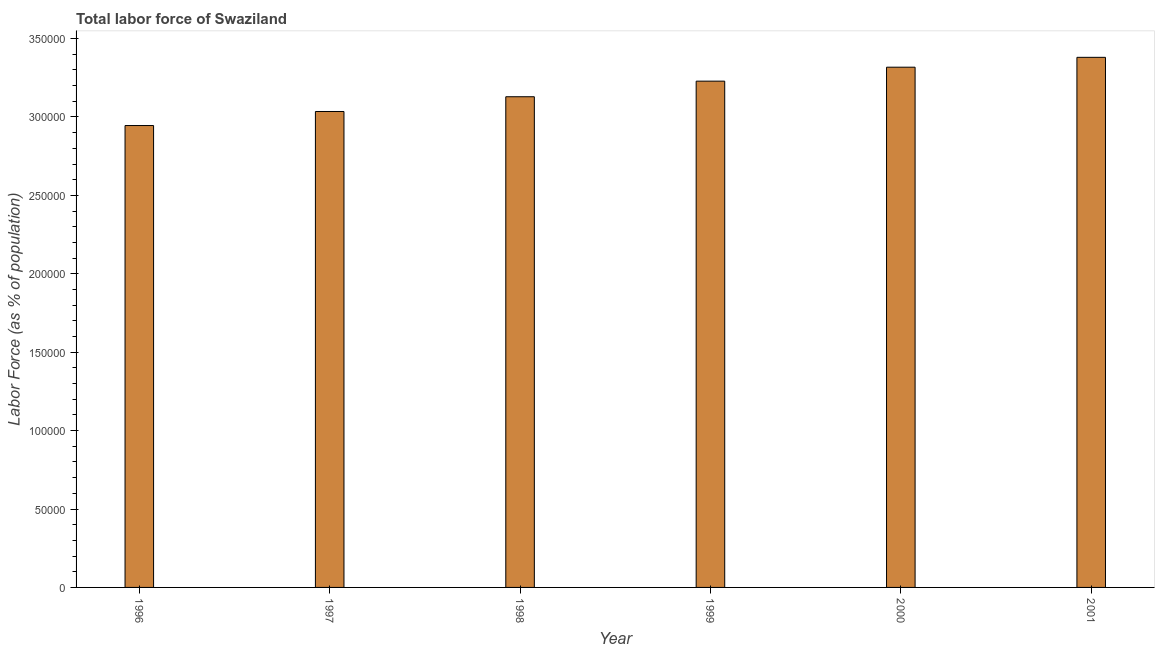Does the graph contain any zero values?
Give a very brief answer. No. Does the graph contain grids?
Your answer should be compact. No. What is the title of the graph?
Make the answer very short. Total labor force of Swaziland. What is the label or title of the X-axis?
Your answer should be compact. Year. What is the label or title of the Y-axis?
Your answer should be very brief. Labor Force (as % of population). What is the total labor force in 1999?
Make the answer very short. 3.23e+05. Across all years, what is the maximum total labor force?
Your response must be concise. 3.38e+05. Across all years, what is the minimum total labor force?
Make the answer very short. 2.95e+05. In which year was the total labor force maximum?
Make the answer very short. 2001. In which year was the total labor force minimum?
Make the answer very short. 1996. What is the sum of the total labor force?
Offer a very short reply. 1.90e+06. What is the difference between the total labor force in 1996 and 1998?
Offer a terse response. -1.84e+04. What is the average total labor force per year?
Keep it short and to the point. 3.17e+05. What is the median total labor force?
Your answer should be compact. 3.18e+05. What is the ratio of the total labor force in 1996 to that in 1998?
Your response must be concise. 0.94. Is the difference between the total labor force in 1996 and 2000 greater than the difference between any two years?
Your response must be concise. No. What is the difference between the highest and the second highest total labor force?
Offer a very short reply. 6291. What is the difference between the highest and the lowest total labor force?
Give a very brief answer. 4.35e+04. How many years are there in the graph?
Provide a succinct answer. 6. Are the values on the major ticks of Y-axis written in scientific E-notation?
Offer a very short reply. No. What is the Labor Force (as % of population) in 1996?
Provide a short and direct response. 2.95e+05. What is the Labor Force (as % of population) in 1997?
Offer a terse response. 3.04e+05. What is the Labor Force (as % of population) of 1998?
Your answer should be compact. 3.13e+05. What is the Labor Force (as % of population) in 1999?
Offer a very short reply. 3.23e+05. What is the Labor Force (as % of population) of 2000?
Provide a short and direct response. 3.32e+05. What is the Labor Force (as % of population) in 2001?
Keep it short and to the point. 3.38e+05. What is the difference between the Labor Force (as % of population) in 1996 and 1997?
Your response must be concise. -8958. What is the difference between the Labor Force (as % of population) in 1996 and 1998?
Your answer should be very brief. -1.84e+04. What is the difference between the Labor Force (as % of population) in 1996 and 1999?
Keep it short and to the point. -2.83e+04. What is the difference between the Labor Force (as % of population) in 1996 and 2000?
Your answer should be very brief. -3.72e+04. What is the difference between the Labor Force (as % of population) in 1996 and 2001?
Provide a short and direct response. -4.35e+04. What is the difference between the Labor Force (as % of population) in 1997 and 1998?
Offer a terse response. -9414. What is the difference between the Labor Force (as % of population) in 1997 and 1999?
Ensure brevity in your answer.  -1.94e+04. What is the difference between the Labor Force (as % of population) in 1997 and 2000?
Your answer should be compact. -2.83e+04. What is the difference between the Labor Force (as % of population) in 1997 and 2001?
Make the answer very short. -3.45e+04. What is the difference between the Labor Force (as % of population) in 1998 and 1999?
Give a very brief answer. -9939. What is the difference between the Labor Force (as % of population) in 1998 and 2000?
Provide a succinct answer. -1.88e+04. What is the difference between the Labor Force (as % of population) in 1998 and 2001?
Your answer should be very brief. -2.51e+04. What is the difference between the Labor Force (as % of population) in 1999 and 2000?
Your response must be concise. -8900. What is the difference between the Labor Force (as % of population) in 1999 and 2001?
Give a very brief answer. -1.52e+04. What is the difference between the Labor Force (as % of population) in 2000 and 2001?
Offer a terse response. -6291. What is the ratio of the Labor Force (as % of population) in 1996 to that in 1997?
Offer a very short reply. 0.97. What is the ratio of the Labor Force (as % of population) in 1996 to that in 1998?
Ensure brevity in your answer.  0.94. What is the ratio of the Labor Force (as % of population) in 1996 to that in 1999?
Ensure brevity in your answer.  0.91. What is the ratio of the Labor Force (as % of population) in 1996 to that in 2000?
Make the answer very short. 0.89. What is the ratio of the Labor Force (as % of population) in 1996 to that in 2001?
Your answer should be very brief. 0.87. What is the ratio of the Labor Force (as % of population) in 1997 to that in 1998?
Give a very brief answer. 0.97. What is the ratio of the Labor Force (as % of population) in 1997 to that in 2000?
Provide a short and direct response. 0.92. What is the ratio of the Labor Force (as % of population) in 1997 to that in 2001?
Ensure brevity in your answer.  0.9. What is the ratio of the Labor Force (as % of population) in 1998 to that in 1999?
Provide a succinct answer. 0.97. What is the ratio of the Labor Force (as % of population) in 1998 to that in 2000?
Give a very brief answer. 0.94. What is the ratio of the Labor Force (as % of population) in 1998 to that in 2001?
Ensure brevity in your answer.  0.93. What is the ratio of the Labor Force (as % of population) in 1999 to that in 2001?
Give a very brief answer. 0.95. 